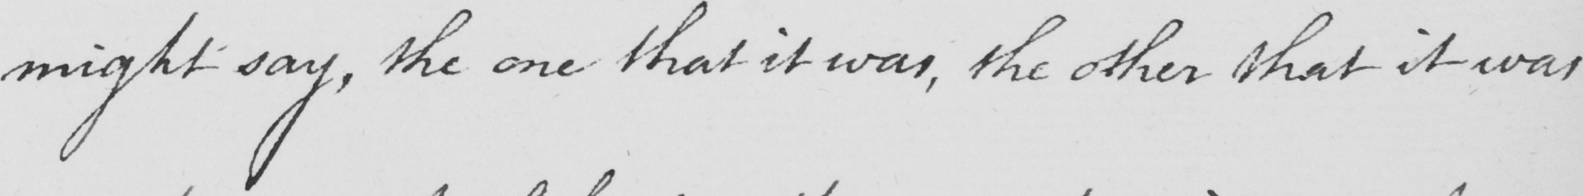Can you read and transcribe this handwriting? might say , the one that it was , the other that it was 